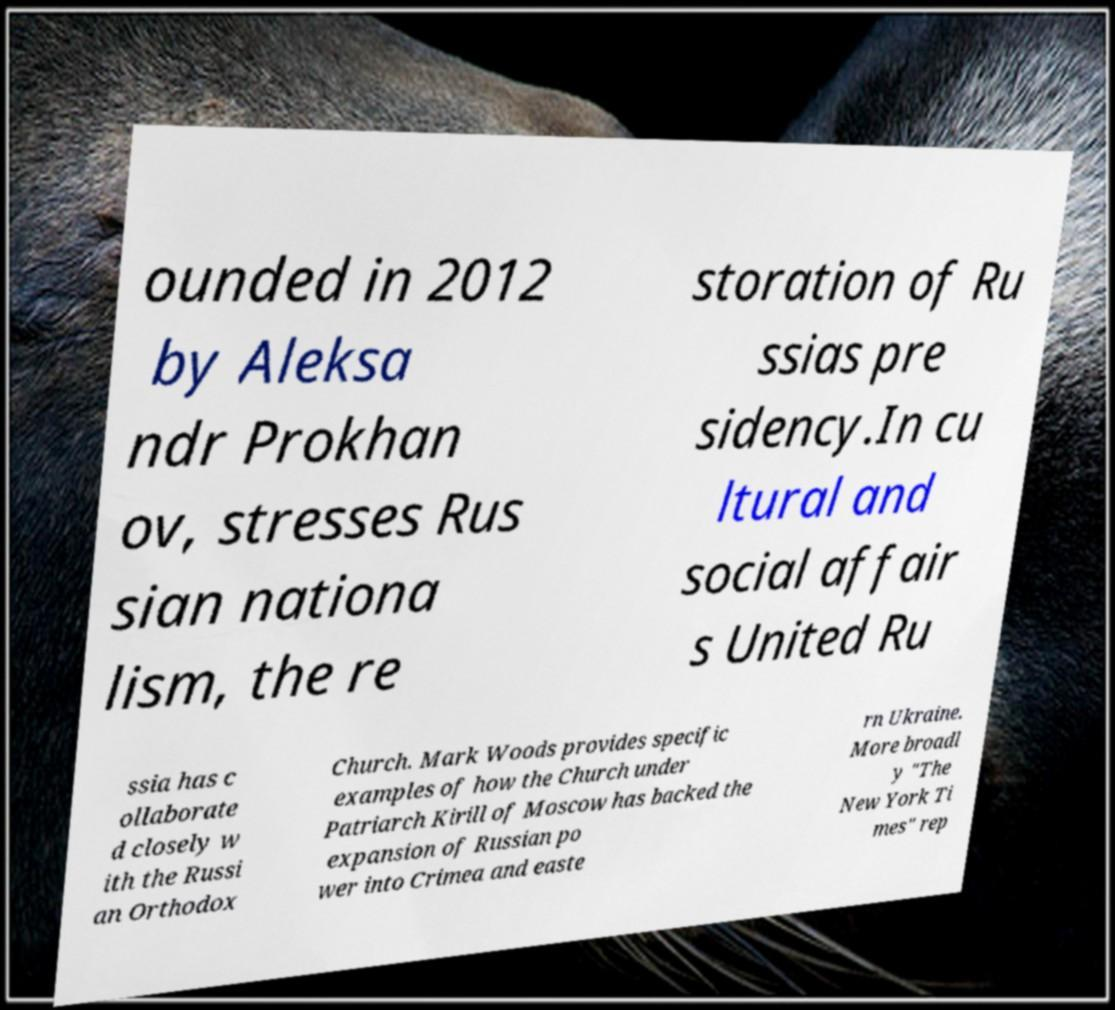I need the written content from this picture converted into text. Can you do that? ounded in 2012 by Aleksa ndr Prokhan ov, stresses Rus sian nationa lism, the re storation of Ru ssias pre sidency.In cu ltural and social affair s United Ru ssia has c ollaborate d closely w ith the Russi an Orthodox Church. Mark Woods provides specific examples of how the Church under Patriarch Kirill of Moscow has backed the expansion of Russian po wer into Crimea and easte rn Ukraine. More broadl y "The New York Ti mes" rep 